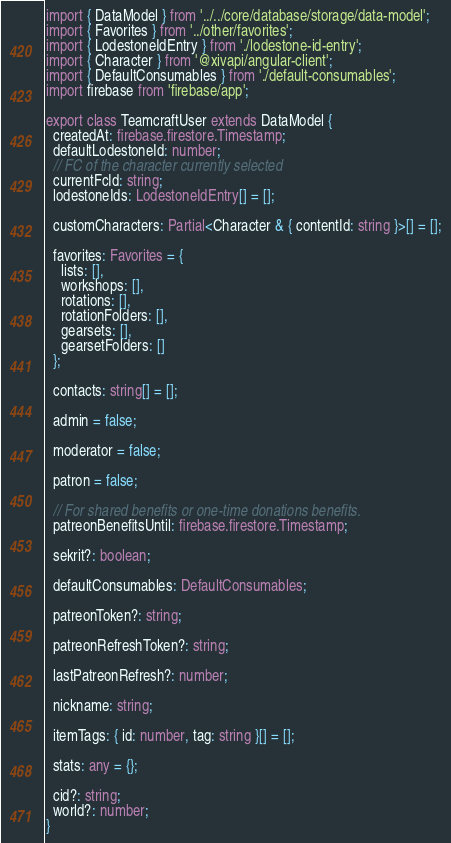Convert code to text. <code><loc_0><loc_0><loc_500><loc_500><_TypeScript_>import { DataModel } from '../../core/database/storage/data-model';
import { Favorites } from '../other/favorites';
import { LodestoneIdEntry } from './lodestone-id-entry';
import { Character } from '@xivapi/angular-client';
import { DefaultConsumables } from './default-consumables';
import firebase from 'firebase/app';

export class TeamcraftUser extends DataModel {
  createdAt: firebase.firestore.Timestamp;
  defaultLodestoneId: number;
  // FC of the character currently selected
  currentFcId: string;
  lodestoneIds: LodestoneIdEntry[] = [];

  customCharacters: Partial<Character & { contentId: string }>[] = [];

  favorites: Favorites = {
    lists: [],
    workshops: [],
    rotations: [],
    rotationFolders: [],
    gearsets: [],
    gearsetFolders: []
  };

  contacts: string[] = [];

  admin = false;

  moderator = false;

  patron = false;

  // For shared benefits or one-time donations benefits.
  patreonBenefitsUntil: firebase.firestore.Timestamp;

  sekrit?: boolean;

  defaultConsumables: DefaultConsumables;

  patreonToken?: string;

  patreonRefreshToken?: string;

  lastPatreonRefresh?: number;

  nickname: string;

  itemTags: { id: number, tag: string }[] = [];

  stats: any = {};

  cid?: string;
  world?: number;
}
</code> 